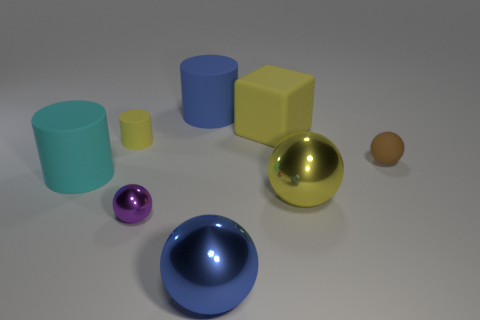Subtract all tiny cylinders. How many cylinders are left? 2 Add 1 cylinders. How many objects exist? 9 Subtract all cyan cylinders. How many cylinders are left? 2 Subtract 2 cylinders. How many cylinders are left? 1 Add 6 small brown cylinders. How many small brown cylinders exist? 6 Subtract 0 purple blocks. How many objects are left? 8 Subtract all cylinders. How many objects are left? 5 Subtract all gray spheres. Subtract all gray cylinders. How many spheres are left? 4 Subtract all cyan cylinders. How many blue blocks are left? 0 Subtract all large blue things. Subtract all tiny green objects. How many objects are left? 6 